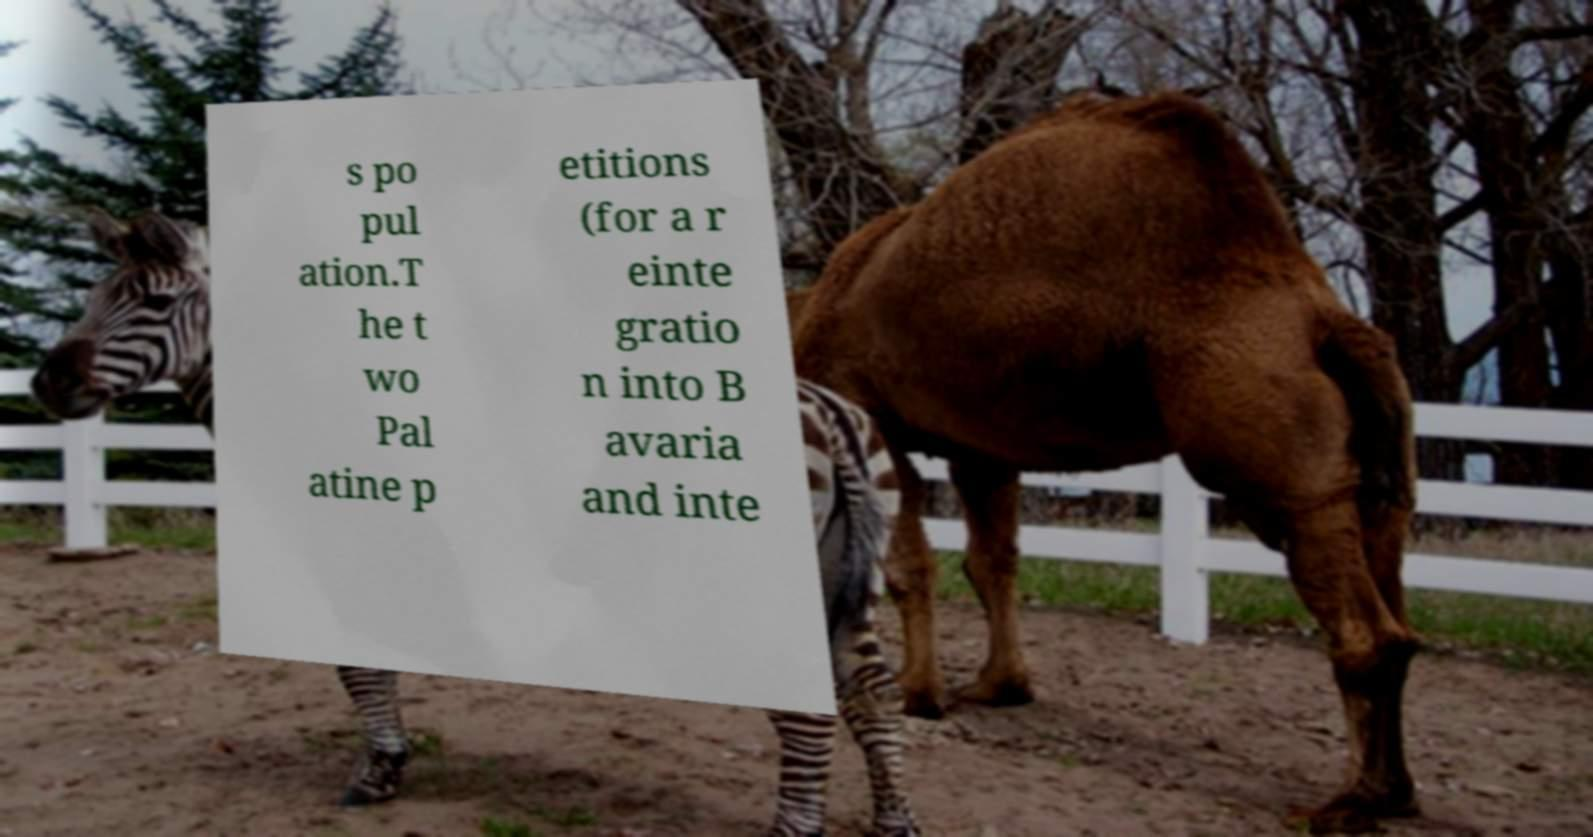For documentation purposes, I need the text within this image transcribed. Could you provide that? s po pul ation.T he t wo Pal atine p etitions (for a r einte gratio n into B avaria and inte 